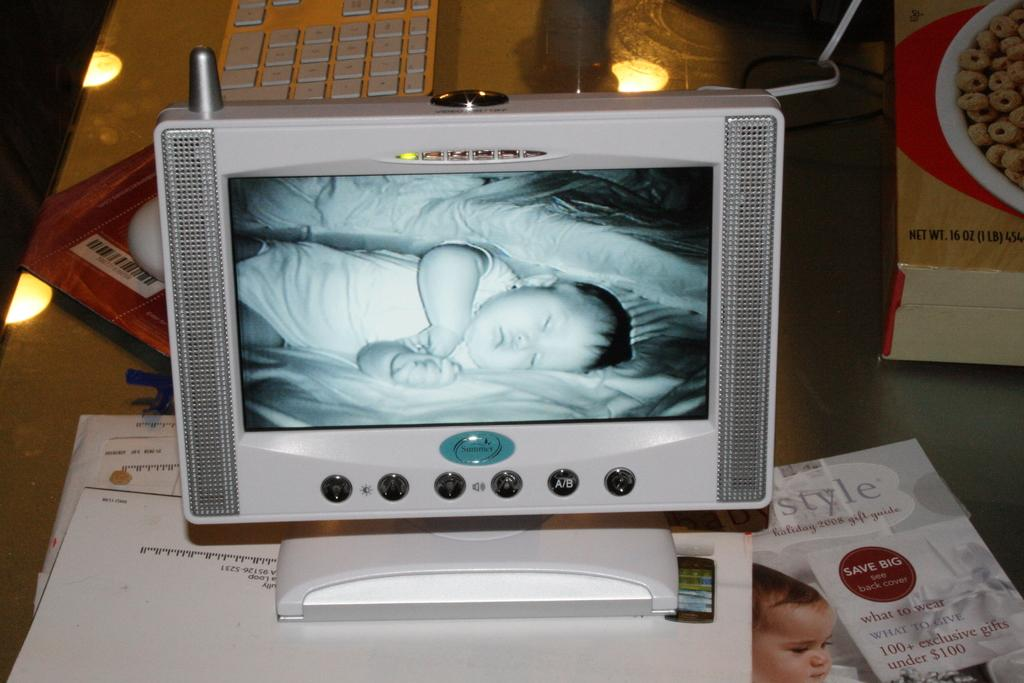<image>
Write a terse but informative summary of the picture. A holiday gift guide from 2008 advertises 100+ exclusive gifts under $100, and lies next to a monitor showing a sleeping baby. 